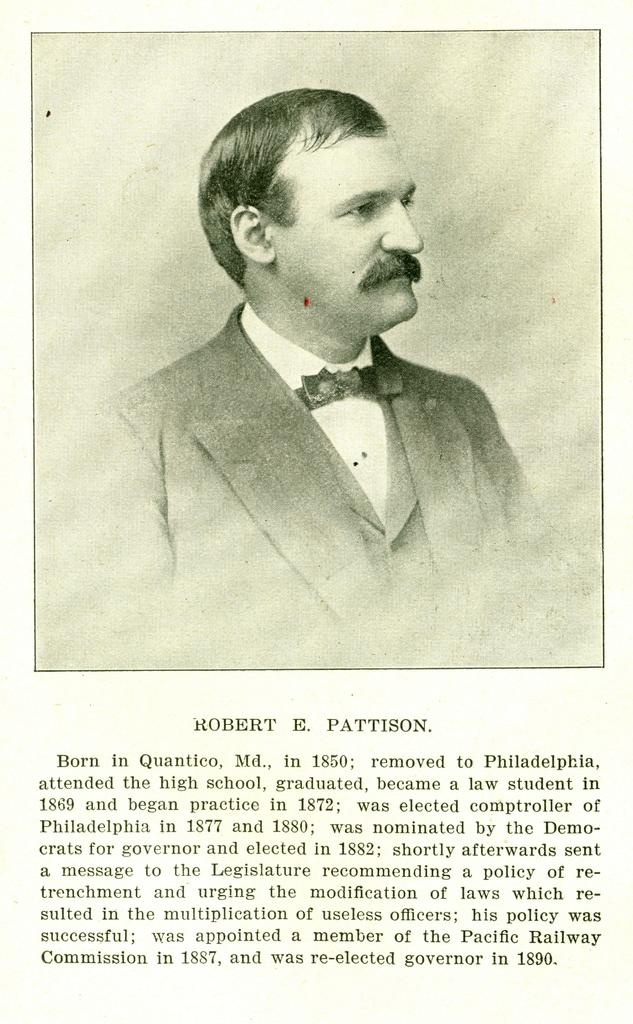Who is the main subject in the image? There is a man in the center of the image. What else can be seen at the bottom of the image? There is text at the bottom of the image. What type of string is being used to cover the man's face in the image? There is no string or covering on the man's face in the image. 